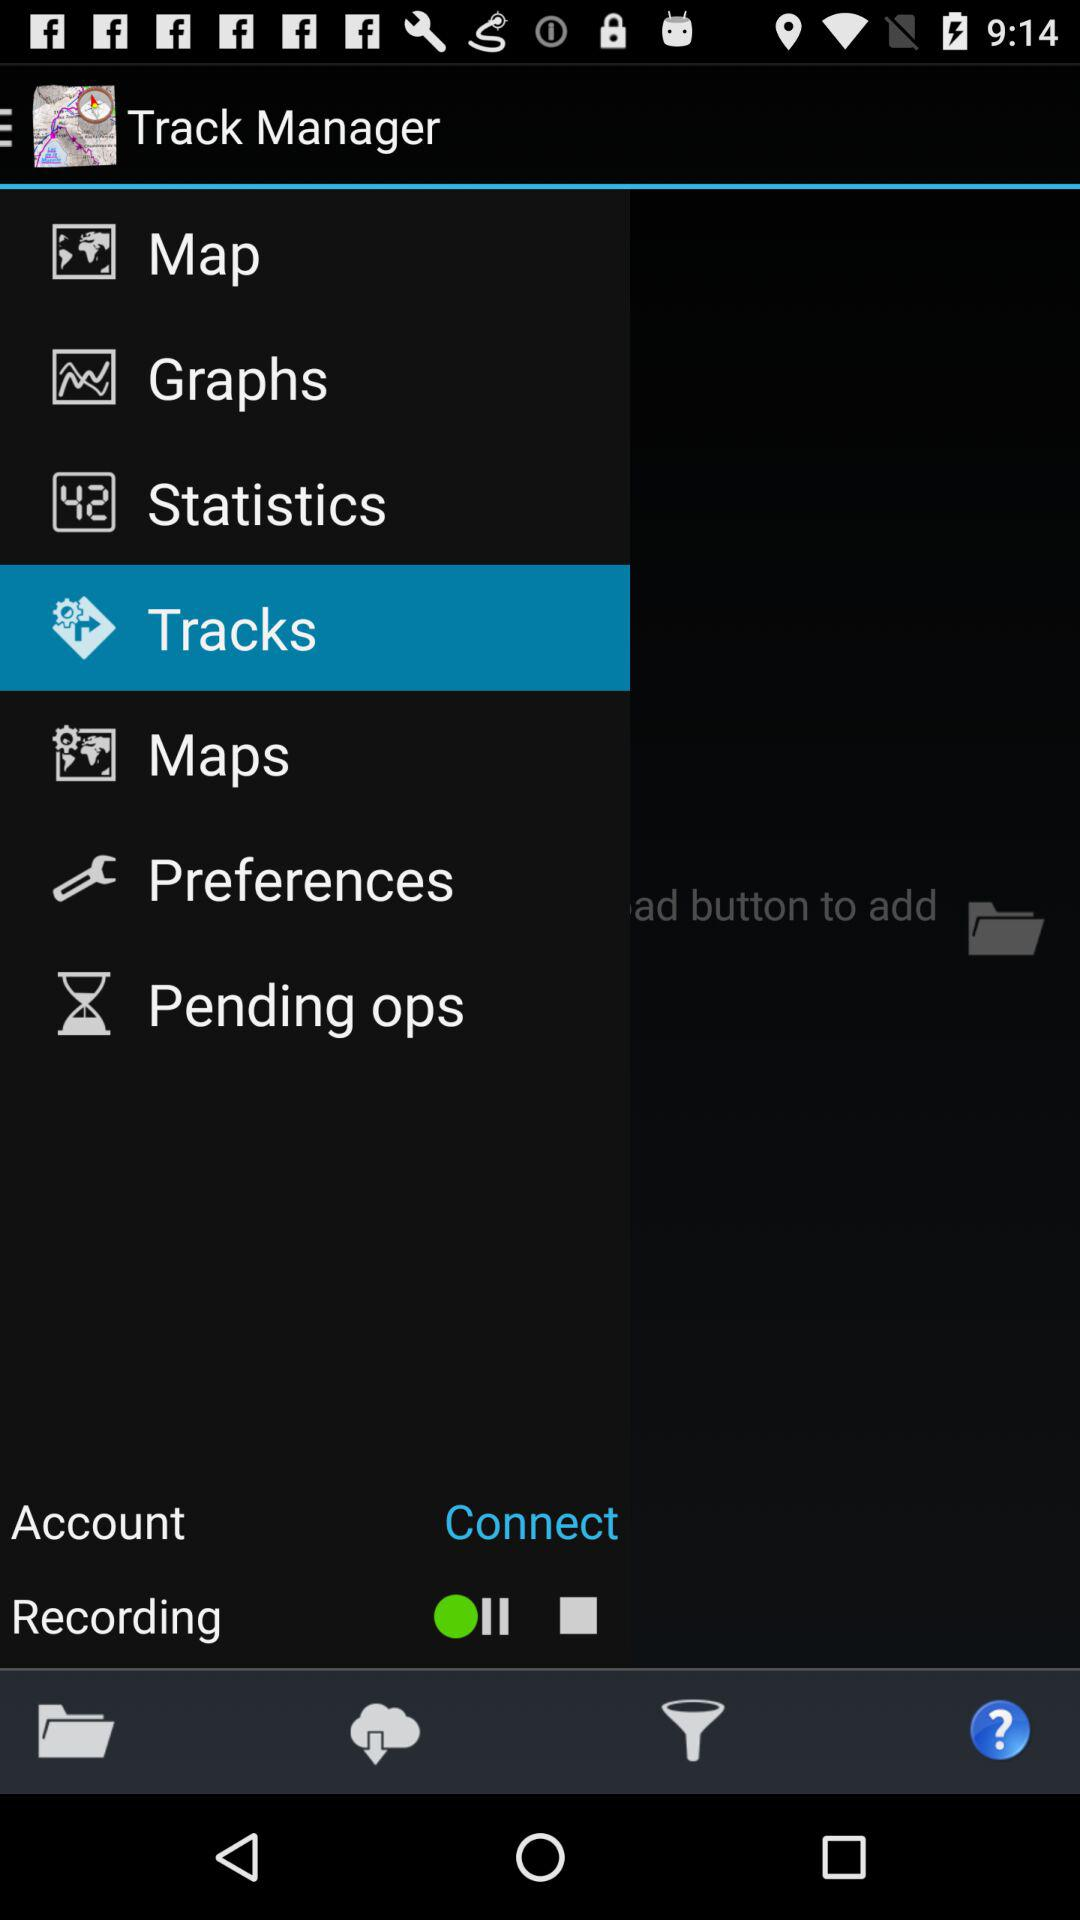What is the selected item? The selected item is "Tracks". 